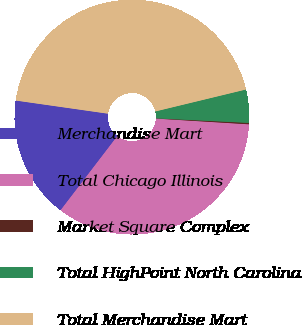Convert chart to OTSL. <chart><loc_0><loc_0><loc_500><loc_500><pie_chart><fcel>Merchandise Mart<fcel>Total Chicago Illinois<fcel>Market Square Complex<fcel>Total HighPoint North Carolina<fcel>Total Merchandise Mart<nl><fcel>16.86%<fcel>34.41%<fcel>0.19%<fcel>4.57%<fcel>43.96%<nl></chart> 